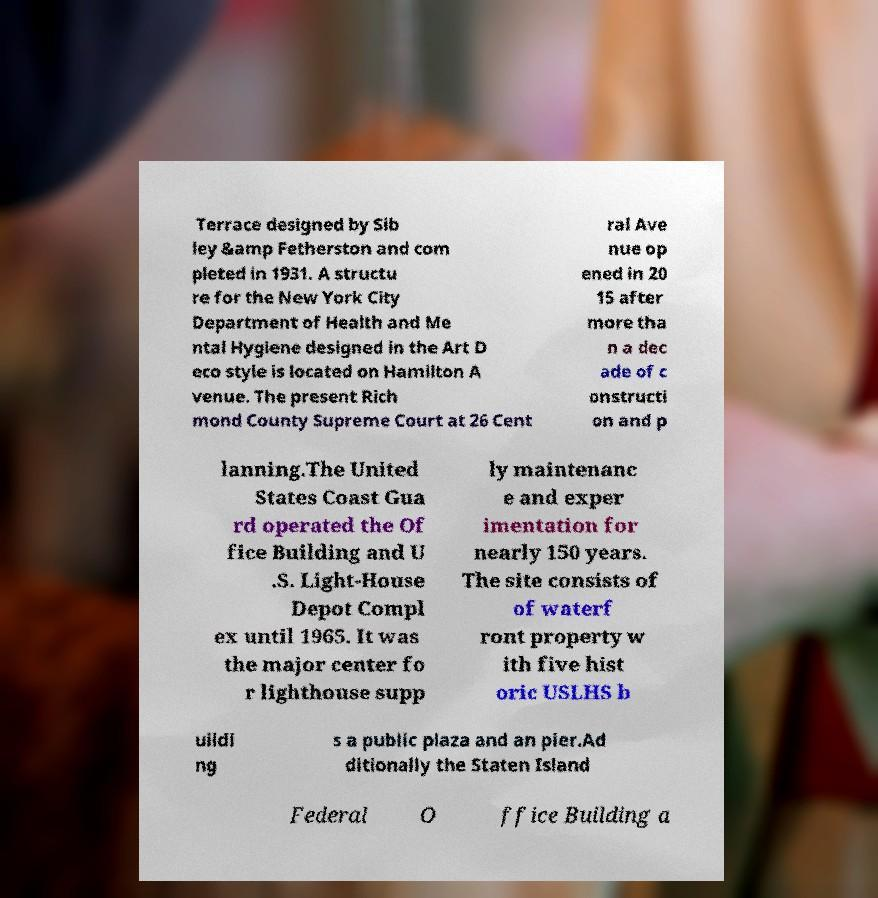I need the written content from this picture converted into text. Can you do that? Terrace designed by Sib ley &amp Fetherston and com pleted in 1931. A structu re for the New York City Department of Health and Me ntal Hygiene designed in the Art D eco style is located on Hamilton A venue. The present Rich mond County Supreme Court at 26 Cent ral Ave nue op ened in 20 15 after more tha n a dec ade of c onstructi on and p lanning.The United States Coast Gua rd operated the Of fice Building and U .S. Light-House Depot Compl ex until 1965. It was the major center fo r lighthouse supp ly maintenanc e and exper imentation for nearly 150 years. The site consists of of waterf ront property w ith five hist oric USLHS b uildi ng s a public plaza and an pier.Ad ditionally the Staten Island Federal O ffice Building a 